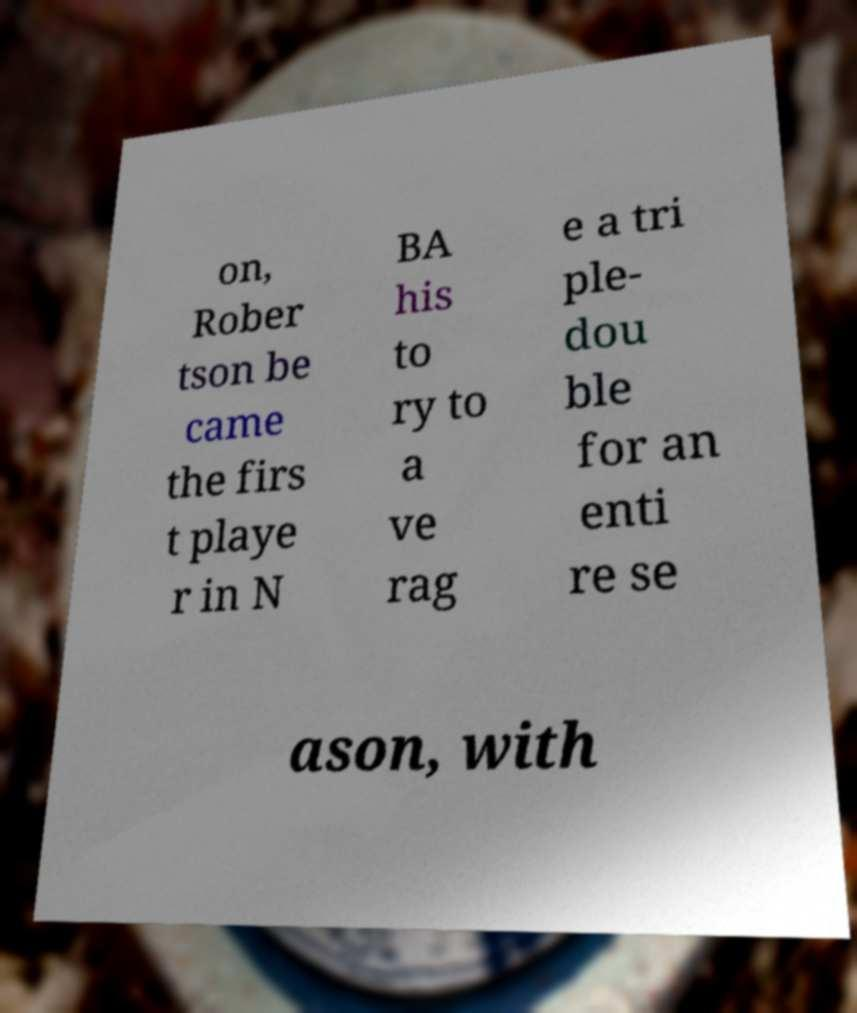What messages or text are displayed in this image? I need them in a readable, typed format. on, Rober tson be came the firs t playe r in N BA his to ry to a ve rag e a tri ple- dou ble for an enti re se ason, with 